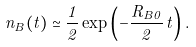Convert formula to latex. <formula><loc_0><loc_0><loc_500><loc_500>n _ { B } ( t ) \simeq \frac { 1 } { 2 } \exp \left ( - \frac { R _ { B 0 } } { 2 } \, t \right ) .</formula> 